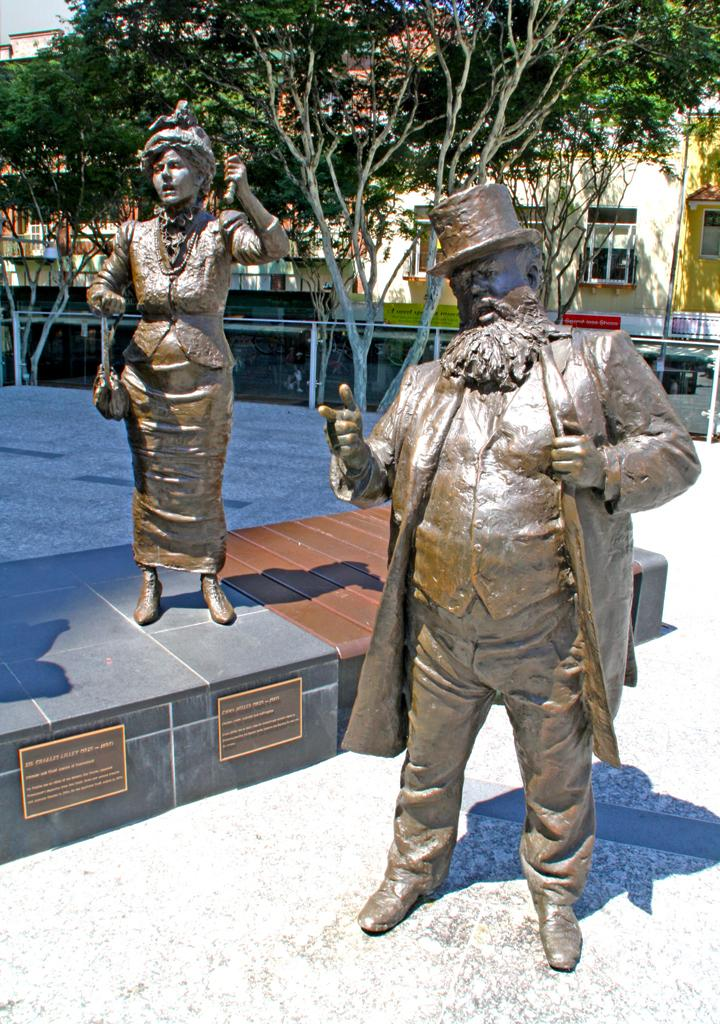How many statues are in the image? There are two statues in the image. Can you describe the statues in terms of gender and location? One statue is of a woman, and it is located towards the top left. The other statue is of a man, and it is located towards the right. What is the color of the statues? The statues are brown in color. What can be seen in the background of the image? Trees and buildings are visible at the top of the image. What type of competition is taking place between the statues in the image? There is no competition taking place between the statues in the image; they are simply standing in their respective locations. Can you tell me which statue has a knee injury in the image? There is no indication of any injuries or medical conditions in the image, as it features statues that are not living beings. 